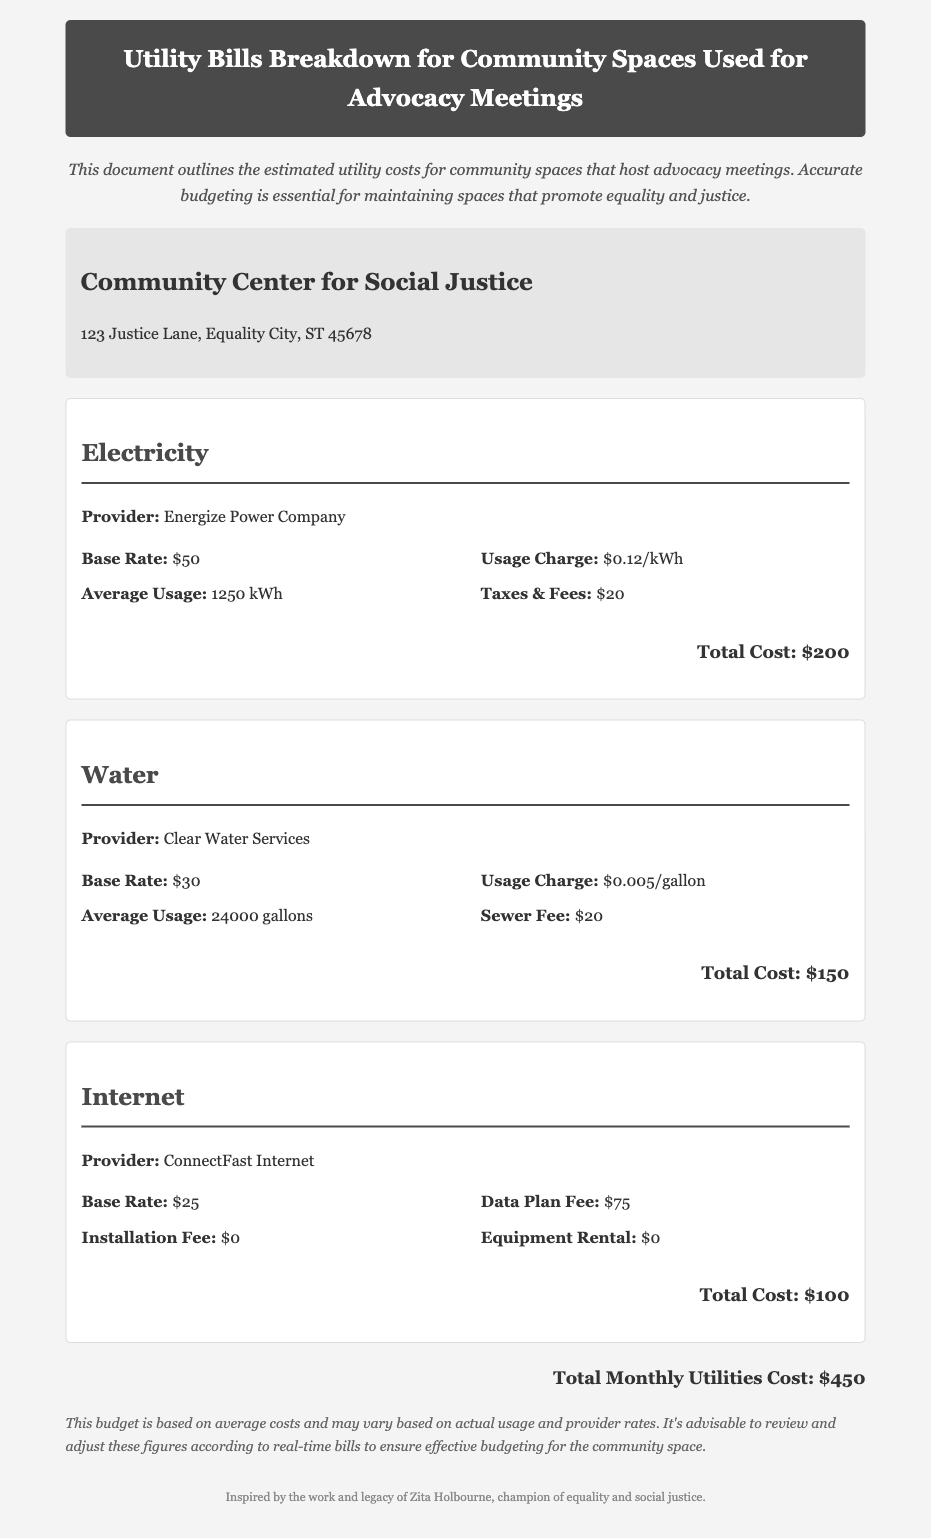What is the total monthly utilities cost? The total monthly utilities cost is calculated by summing all utility costs outlined in the document, which is $200 for electricity, $150 for water, and $100 for internet.
Answer: $450 Who is the electricity provider? The document specifies the provider for electricity services used by the community space.
Answer: Energize Power Company What is the average usage of water? The average usage of water is indicated in the document and represents the estimated amount consumed in gallons.
Answer: 24000 gallons What is the base rate for internet service? The base rate for internet services is directly listed in the utility breakdown section.
Answer: $25 What additional fee is included in the water charges? The document lists an additional fee related to the water service and its purpose in the overall charges.
Answer: Sewer Fee How much is the usage charge for electricity? The usage charge for electricity is mentioned in the electricity section of the document.
Answer: $0.12/kWh What is the total cost for water? The total cost for water is provided in the water utility section and combines different charges detailed there.
Answer: $150 What space is the utility bill for? The document specifies the name of the community space associated with these utility bills.
Answer: Community Center for Social Justice Is there an installation fee for internet services? The document specifies if there is any installation fee for the internet service provided.
Answer: $0 